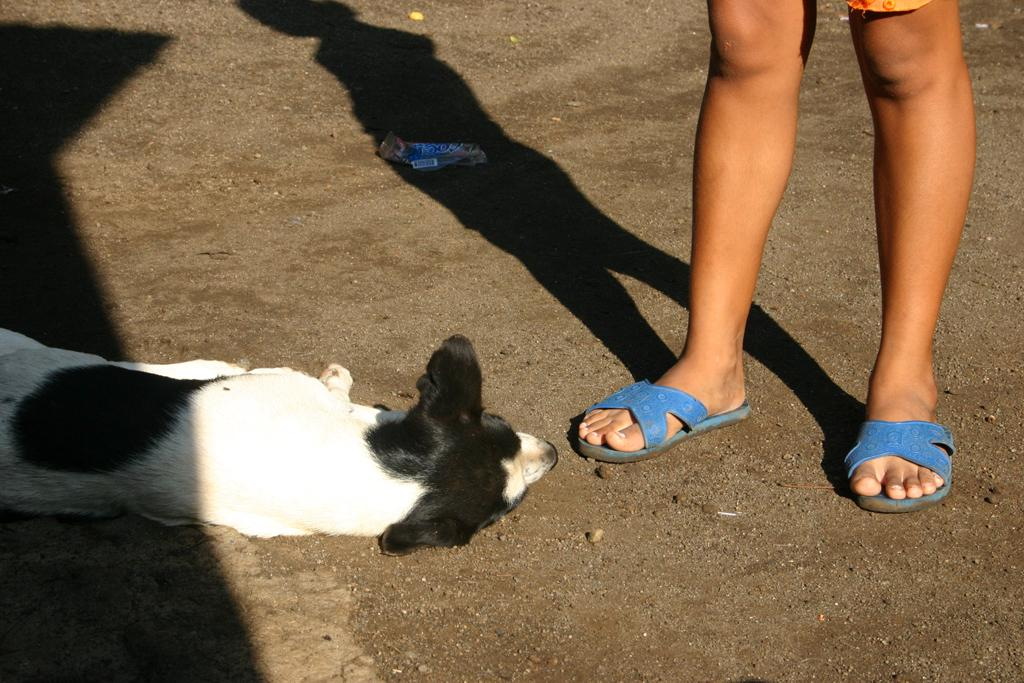What is visible in the foreground of the picture? There are a person's legs and a dog lying on the ground in the foreground of the picture. Can you describe the position of the dog in the image? The dog is lying on the ground in the foreground of the picture. What type of feather can be seen in the dog's fur in the image? There is no feather visible in the dog's fur in the image. How many nuts are scattered around the dog in the image? There are no nuts present in the image. 